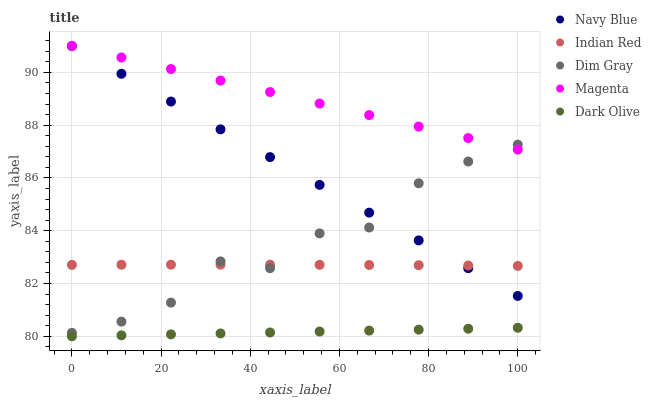Does Dark Olive have the minimum area under the curve?
Answer yes or no. Yes. Does Magenta have the maximum area under the curve?
Answer yes or no. Yes. Does Navy Blue have the minimum area under the curve?
Answer yes or no. No. Does Navy Blue have the maximum area under the curve?
Answer yes or no. No. Is Dark Olive the smoothest?
Answer yes or no. Yes. Is Dim Gray the roughest?
Answer yes or no. Yes. Is Navy Blue the smoothest?
Answer yes or no. No. Is Navy Blue the roughest?
Answer yes or no. No. Does Dark Olive have the lowest value?
Answer yes or no. Yes. Does Navy Blue have the lowest value?
Answer yes or no. No. Does Magenta have the highest value?
Answer yes or no. Yes. Does Dim Gray have the highest value?
Answer yes or no. No. Is Indian Red less than Magenta?
Answer yes or no. Yes. Is Magenta greater than Indian Red?
Answer yes or no. Yes. Does Indian Red intersect Navy Blue?
Answer yes or no. Yes. Is Indian Red less than Navy Blue?
Answer yes or no. No. Is Indian Red greater than Navy Blue?
Answer yes or no. No. Does Indian Red intersect Magenta?
Answer yes or no. No. 